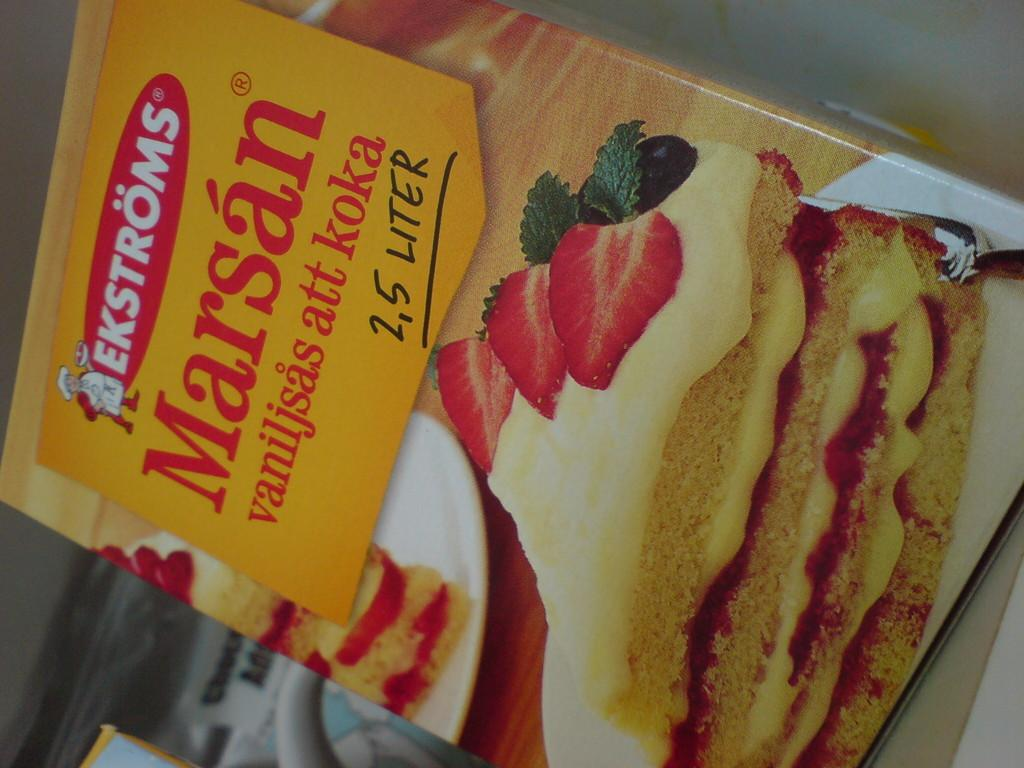What is the main object in the image? There is a box in the image. What is depicted on the box? The box has a picture of breads stuffed with cream and topped with strawberry slices. Where are the breads placed in the image? The breads are on a plate. What can be found on the top of the box? There is text on the top of the box. What route does the fang take to reach the breads in the image? There is no fang present in the image, so it cannot take a route to reach the breads. 